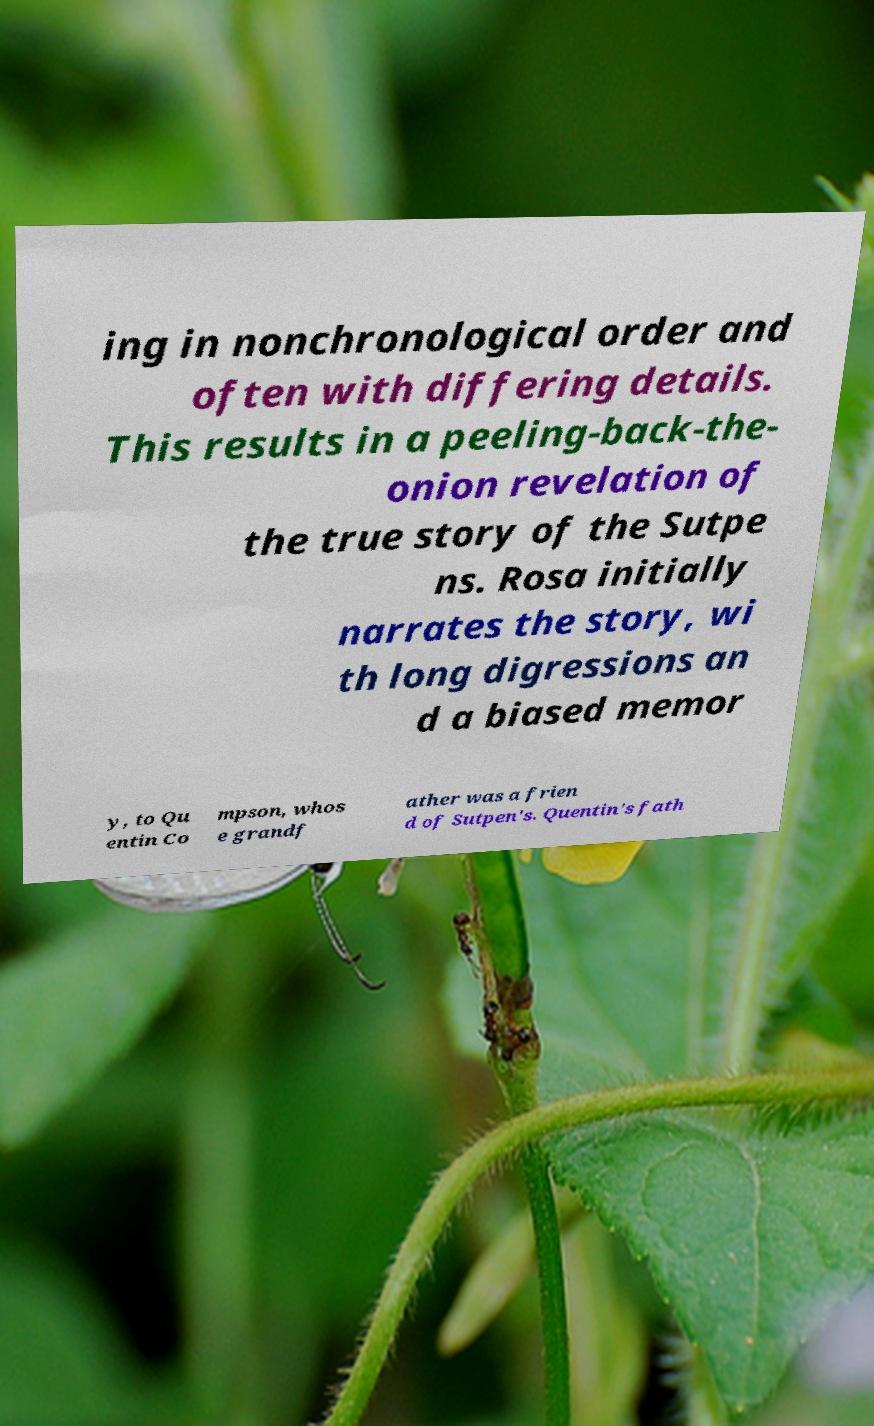There's text embedded in this image that I need extracted. Can you transcribe it verbatim? ing in nonchronological order and often with differing details. This results in a peeling-back-the- onion revelation of the true story of the Sutpe ns. Rosa initially narrates the story, wi th long digressions an d a biased memor y, to Qu entin Co mpson, whos e grandf ather was a frien d of Sutpen's. Quentin's fath 